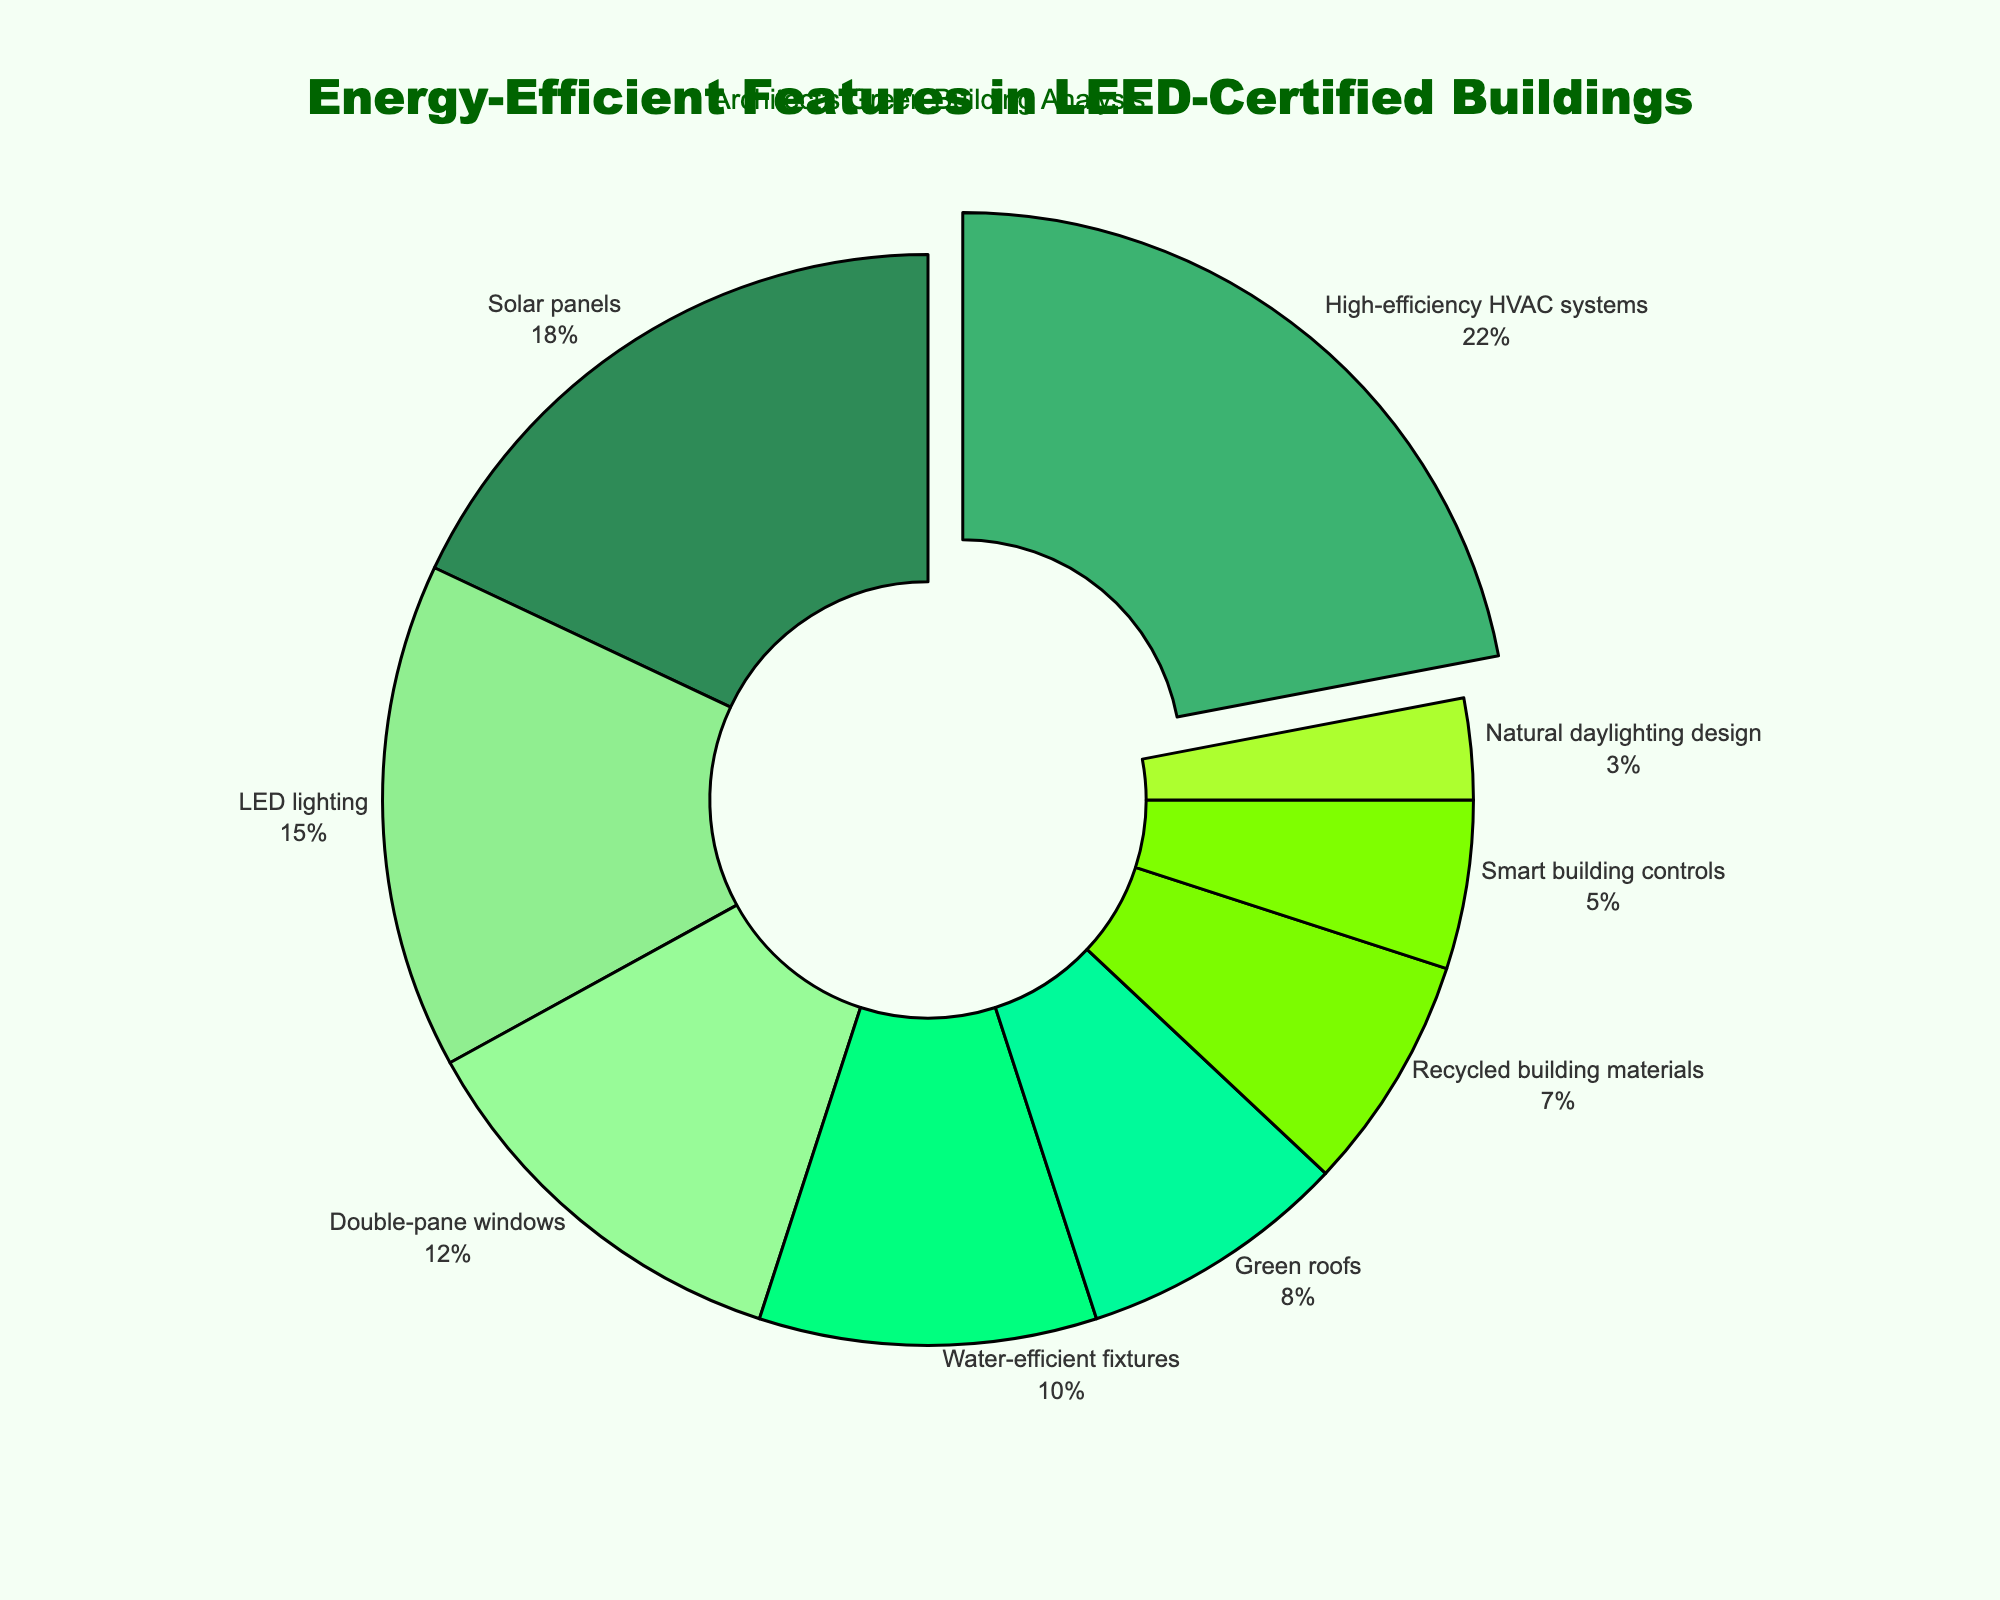What's the largest energy-efficient feature in LEED-certified buildings? The largest feature is pulled away from the center of the pie chart, making it visually distinct. From the pie chart, the largest segment belongs to High-efficiency HVAC systems, which is also pulled out.
Answer: High-efficiency HVAC systems What's the total percentage of all energy-efficient features except Solar panels and Green roofs? To find this, sum the percentages for all features except Solar panels (18%) and Green roofs (8%). The total percentage is: 100% - (18% + 8%) = 74%.
Answer: 74% Which feature has a higher percentage: LED lighting or Double-pane windows? From the pie chart, compare the percentages of LED lighting (15%) and Double-pane windows (12%). LED lighting has a higher percentage.
Answer: LED lighting How many more percent does High-efficiency HVAC systems have compared to Smart building controls? Subtract the percentage of Smart building controls (5%) from the percentage of High-efficiency HVAC systems (22%): 22% - 5% = 17%.
Answer: 17% What's the sum of the percentages for the top three energy-efficient features? Sum the percentages of High-efficiency HVAC systems (22%), Solar panels (18%), and LED lighting (15%): 22% + 18% + 15% = 55%.
Answer: 55% Which color represents the feature with the lowest percentage? From the pie chart, Natural daylighting design has the lowest percentage (3%). This segment is colored with the lightest shade of green.
Answer: Light green What percentage of all features does Water-efficient fixtures and Recycled building materials together occupy? Add the percentages for Water-efficient fixtures (10%) and Recycled building materials (7%): 10% + 7% = 17%.
Answer: 17% If Solar panels and High-efficiency HVAC systems were combined into a single feature, what would their combined percentage be? Add the percentages for Solar panels (18%) and High-efficiency HVAC systems (22%): 18% + 22% = 40%.
Answer: 40% Which feature has a lower percentage, Green roofs or Smart building controls? Compare the percentages of Green roofs (8%) and Smart building controls (5%). Smart building controls has a lower percentage.
Answer: Smart building controls What's the difference in percentage between Double-pane windows and LED lighting? Subtract the percentage of Double-pane windows (12%) from the percentage of LED lighting (15%): 15% - 12% = 3%.
Answer: 3% 